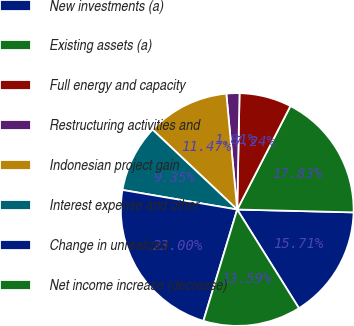Convert chart to OTSL. <chart><loc_0><loc_0><loc_500><loc_500><pie_chart><fcel>New investments (a)<fcel>Existing assets (a)<fcel>Full energy and capacity<fcel>Restructuring activities and<fcel>Indonesian project gain<fcel>Interest expense and other<fcel>Change in unrealized<fcel>Net income increase (decrease)<nl><fcel>15.71%<fcel>17.83%<fcel>7.24%<fcel>1.81%<fcel>11.47%<fcel>9.35%<fcel>23.0%<fcel>13.59%<nl></chart> 